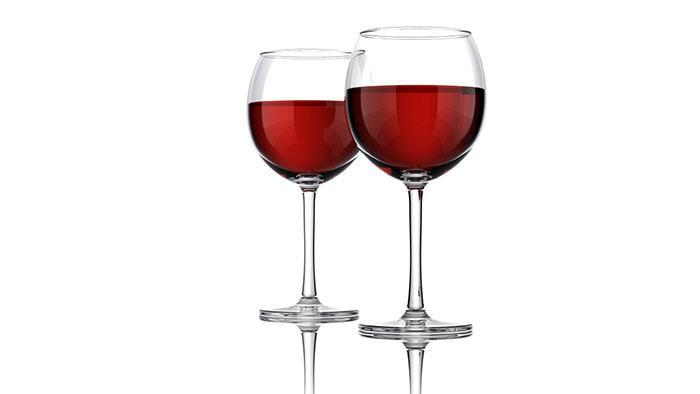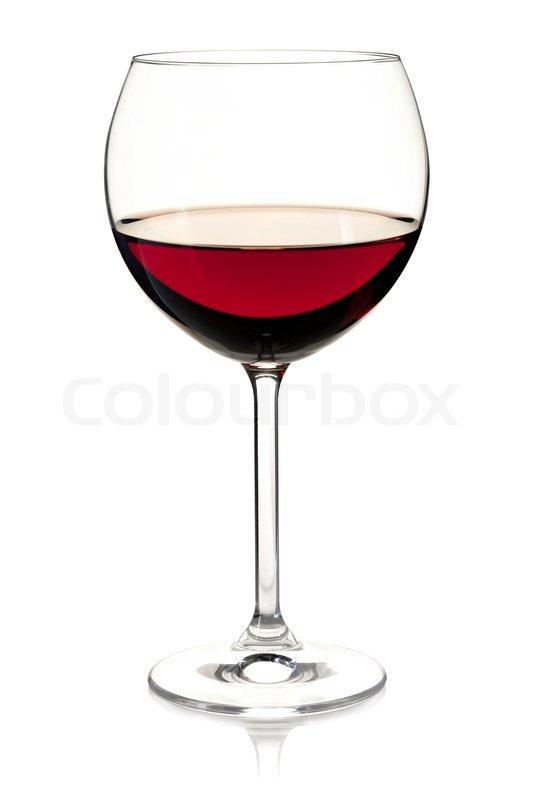The first image is the image on the left, the second image is the image on the right. Considering the images on both sides, is "There is at least two wine glasses in the left image." valid? Answer yes or no. Yes. The first image is the image on the left, the second image is the image on the right. Analyze the images presented: Is the assertion "The left image shows two glasses of red wine while the right image shows one" valid? Answer yes or no. Yes. 